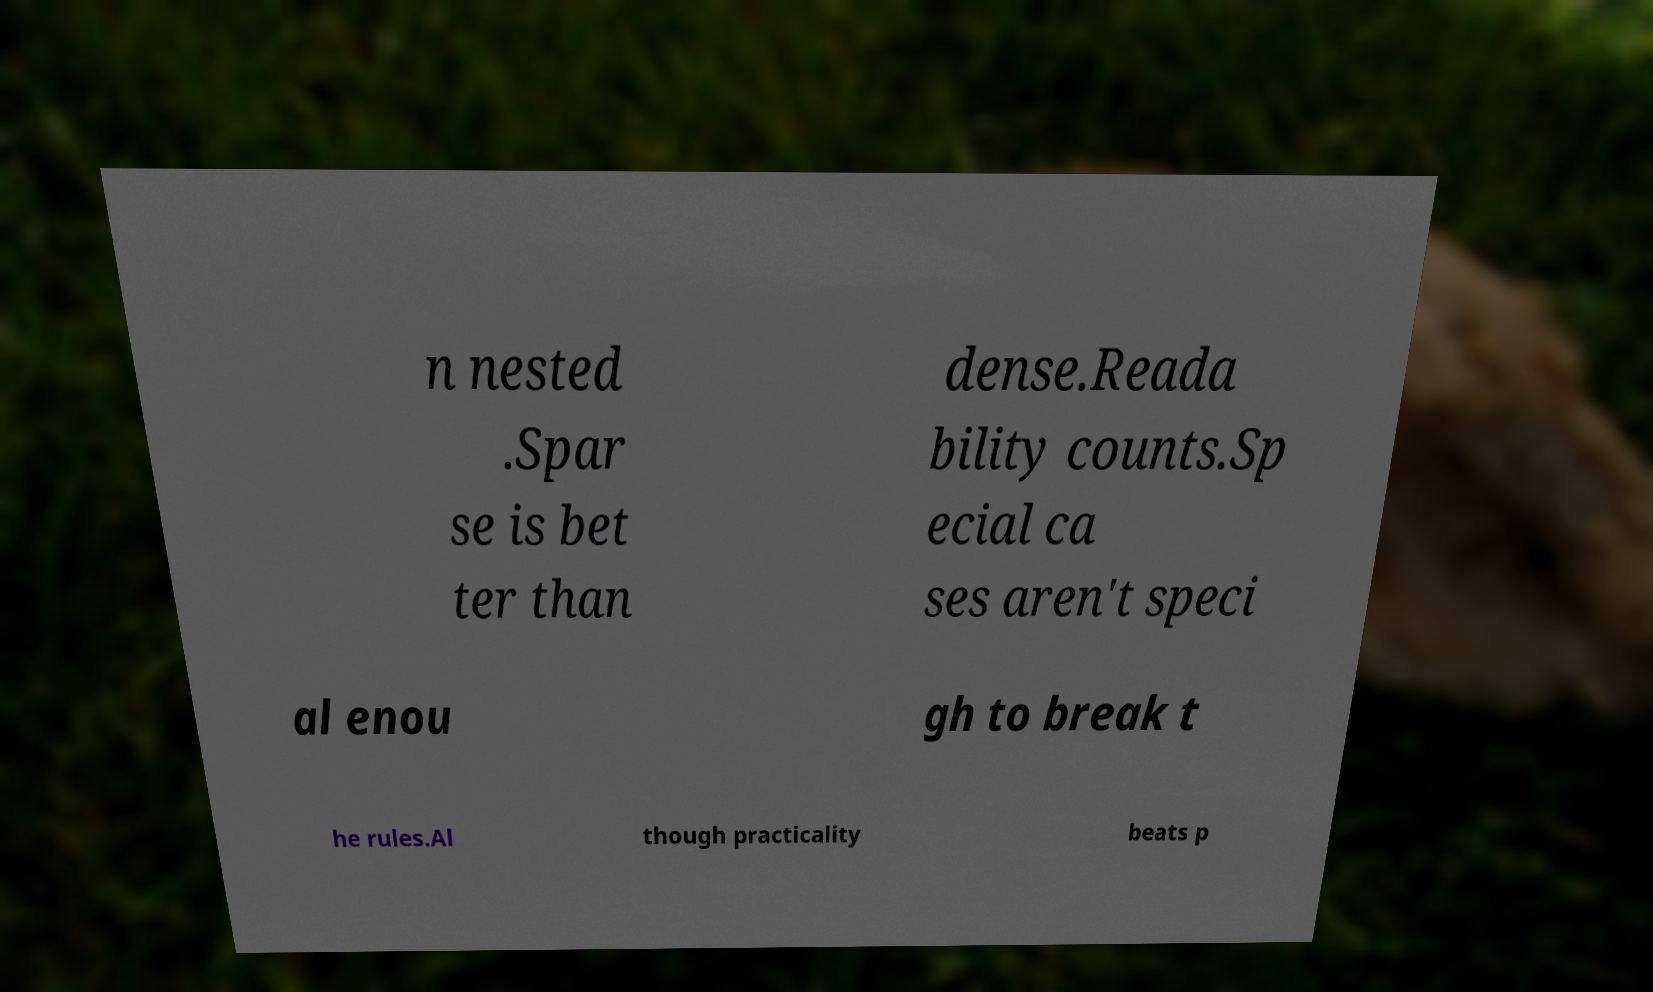Can you accurately transcribe the text from the provided image for me? n nested .Spar se is bet ter than dense.Reada bility counts.Sp ecial ca ses aren't speci al enou gh to break t he rules.Al though practicality beats p 